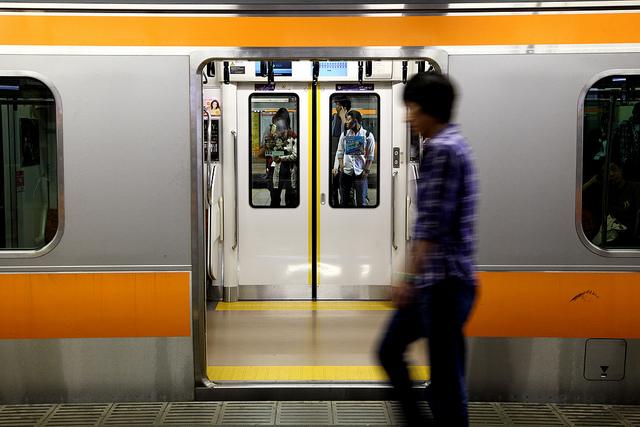What kind of transportation is this?
Quick response, please. Train. What is the train siding made of?
Keep it brief. Metal. What is in right foreground?
Quick response, please. Man. Is the man walking?
Write a very short answer. Yes. 